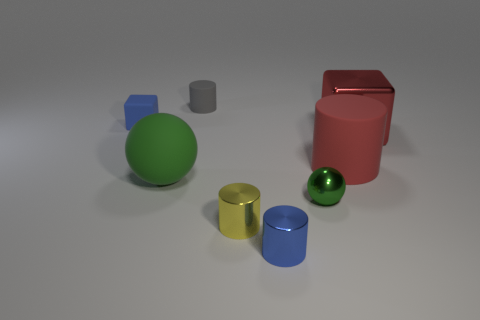What number of other objects are the same size as the red metal cube?
Ensure brevity in your answer.  2. There is another thing that is the same shape as the large green thing; what is its color?
Ensure brevity in your answer.  Green. What is the color of the tiny sphere that is the same material as the yellow object?
Give a very brief answer. Green. Is the number of small matte cubes that are in front of the big rubber ball the same as the number of large yellow rubber objects?
Make the answer very short. Yes. Is the size of the ball that is right of the gray thing the same as the big green rubber thing?
Keep it short and to the point. No. There is a cylinder that is the same size as the red metallic thing; what is its color?
Offer a very short reply. Red. Is there a tiny yellow object left of the small blue object that is in front of the blue object that is behind the rubber sphere?
Offer a terse response. Yes. There is a large thing to the left of the gray object; what material is it?
Offer a very short reply. Rubber. Is the shape of the big metal thing the same as the tiny object behind the small blue matte block?
Make the answer very short. No. Are there the same number of yellow metal things that are behind the red cylinder and blocks right of the yellow metallic object?
Offer a terse response. No. 